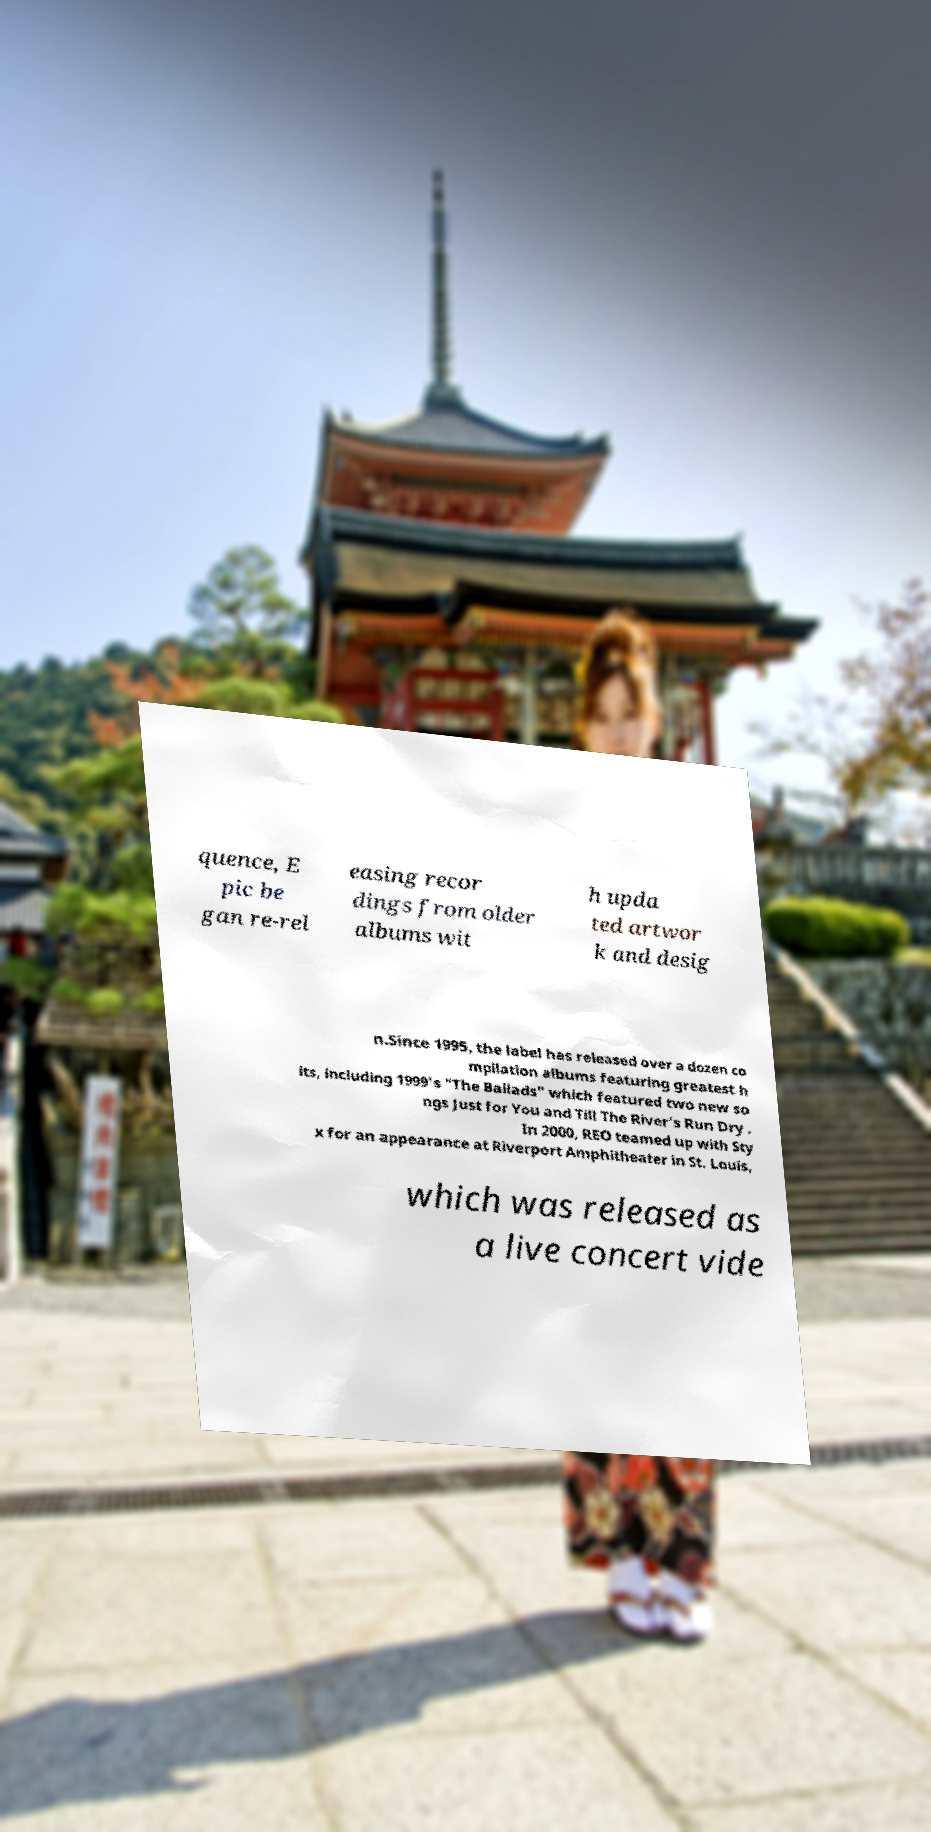Please read and relay the text visible in this image. What does it say? quence, E pic be gan re-rel easing recor dings from older albums wit h upda ted artwor k and desig n.Since 1995, the label has released over a dozen co mpilation albums featuring greatest h its, including 1999's "The Ballads" which featured two new so ngs Just for You and Till The River's Run Dry . In 2000, REO teamed up with Sty x for an appearance at Riverport Amphitheater in St. Louis, which was released as a live concert vide 